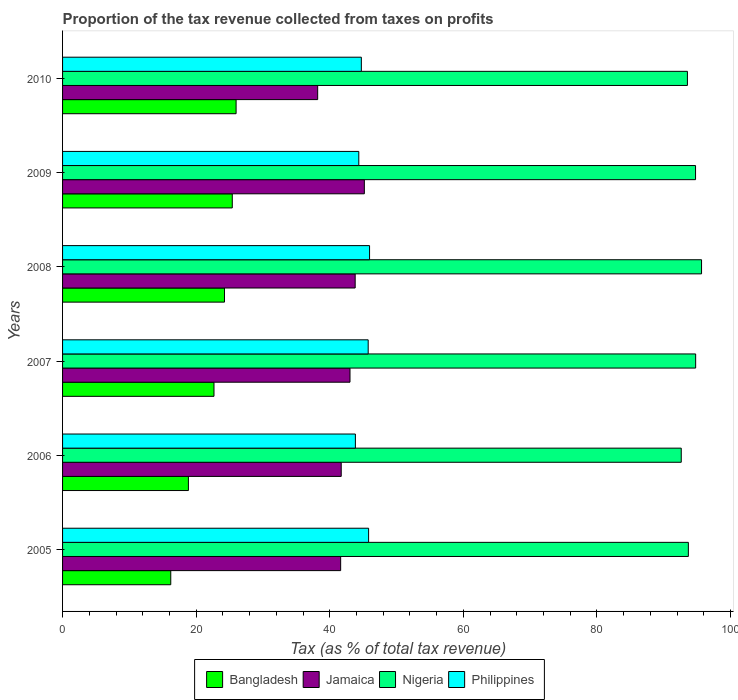How many different coloured bars are there?
Your response must be concise. 4. Are the number of bars per tick equal to the number of legend labels?
Provide a succinct answer. Yes. Are the number of bars on each tick of the Y-axis equal?
Ensure brevity in your answer.  Yes. How many bars are there on the 5th tick from the top?
Provide a short and direct response. 4. What is the proportion of the tax revenue collected in Jamaica in 2006?
Your answer should be compact. 41.72. Across all years, what is the maximum proportion of the tax revenue collected in Jamaica?
Keep it short and to the point. 45.18. Across all years, what is the minimum proportion of the tax revenue collected in Nigeria?
Your response must be concise. 92.63. In which year was the proportion of the tax revenue collected in Jamaica minimum?
Make the answer very short. 2010. What is the total proportion of the tax revenue collected in Nigeria in the graph?
Give a very brief answer. 565.12. What is the difference between the proportion of the tax revenue collected in Nigeria in 2007 and that in 2010?
Provide a succinct answer. 1.23. What is the difference between the proportion of the tax revenue collected in Philippines in 2010 and the proportion of the tax revenue collected in Bangladesh in 2007?
Your answer should be very brief. 22.06. What is the average proportion of the tax revenue collected in Jamaica per year?
Your response must be concise. 42.26. In the year 2008, what is the difference between the proportion of the tax revenue collected in Jamaica and proportion of the tax revenue collected in Nigeria?
Your response must be concise. -51.86. What is the ratio of the proportion of the tax revenue collected in Philippines in 2007 to that in 2009?
Keep it short and to the point. 1.03. Is the difference between the proportion of the tax revenue collected in Jamaica in 2007 and 2010 greater than the difference between the proportion of the tax revenue collected in Nigeria in 2007 and 2010?
Your response must be concise. Yes. What is the difference between the highest and the second highest proportion of the tax revenue collected in Bangladesh?
Give a very brief answer. 0.57. What is the difference between the highest and the lowest proportion of the tax revenue collected in Philippines?
Ensure brevity in your answer.  2.12. What does the 1st bar from the top in 2007 represents?
Your response must be concise. Philippines. What does the 3rd bar from the bottom in 2007 represents?
Offer a terse response. Nigeria. Is it the case that in every year, the sum of the proportion of the tax revenue collected in Nigeria and proportion of the tax revenue collected in Bangladesh is greater than the proportion of the tax revenue collected in Jamaica?
Give a very brief answer. Yes. Are all the bars in the graph horizontal?
Offer a terse response. Yes. How many years are there in the graph?
Provide a short and direct response. 6. Does the graph contain any zero values?
Offer a terse response. No. What is the title of the graph?
Offer a terse response. Proportion of the tax revenue collected from taxes on profits. Does "Vanuatu" appear as one of the legend labels in the graph?
Give a very brief answer. No. What is the label or title of the X-axis?
Ensure brevity in your answer.  Tax (as % of total tax revenue). What is the label or title of the Y-axis?
Keep it short and to the point. Years. What is the Tax (as % of total tax revenue) of Bangladesh in 2005?
Keep it short and to the point. 16.2. What is the Tax (as % of total tax revenue) in Jamaica in 2005?
Keep it short and to the point. 41.64. What is the Tax (as % of total tax revenue) of Nigeria in 2005?
Your response must be concise. 93.7. What is the Tax (as % of total tax revenue) of Philippines in 2005?
Your response must be concise. 45.82. What is the Tax (as % of total tax revenue) of Bangladesh in 2006?
Provide a succinct answer. 18.84. What is the Tax (as % of total tax revenue) in Jamaica in 2006?
Provide a succinct answer. 41.72. What is the Tax (as % of total tax revenue) in Nigeria in 2006?
Ensure brevity in your answer.  92.63. What is the Tax (as % of total tax revenue) of Philippines in 2006?
Ensure brevity in your answer.  43.84. What is the Tax (as % of total tax revenue) in Bangladesh in 2007?
Make the answer very short. 22.67. What is the Tax (as % of total tax revenue) of Jamaica in 2007?
Your answer should be very brief. 43.04. What is the Tax (as % of total tax revenue) in Nigeria in 2007?
Offer a very short reply. 94.79. What is the Tax (as % of total tax revenue) in Philippines in 2007?
Make the answer very short. 45.76. What is the Tax (as % of total tax revenue) in Bangladesh in 2008?
Your response must be concise. 24.24. What is the Tax (as % of total tax revenue) of Jamaica in 2008?
Ensure brevity in your answer.  43.81. What is the Tax (as % of total tax revenue) in Nigeria in 2008?
Make the answer very short. 95.67. What is the Tax (as % of total tax revenue) in Philippines in 2008?
Provide a succinct answer. 45.96. What is the Tax (as % of total tax revenue) of Bangladesh in 2009?
Ensure brevity in your answer.  25.41. What is the Tax (as % of total tax revenue) in Jamaica in 2009?
Your response must be concise. 45.18. What is the Tax (as % of total tax revenue) in Nigeria in 2009?
Provide a short and direct response. 94.77. What is the Tax (as % of total tax revenue) of Philippines in 2009?
Make the answer very short. 44.35. What is the Tax (as % of total tax revenue) of Bangladesh in 2010?
Make the answer very short. 25.98. What is the Tax (as % of total tax revenue) of Jamaica in 2010?
Keep it short and to the point. 38.2. What is the Tax (as % of total tax revenue) in Nigeria in 2010?
Offer a very short reply. 93.55. What is the Tax (as % of total tax revenue) of Philippines in 2010?
Offer a terse response. 44.73. Across all years, what is the maximum Tax (as % of total tax revenue) in Bangladesh?
Offer a terse response. 25.98. Across all years, what is the maximum Tax (as % of total tax revenue) of Jamaica?
Make the answer very short. 45.18. Across all years, what is the maximum Tax (as % of total tax revenue) of Nigeria?
Keep it short and to the point. 95.67. Across all years, what is the maximum Tax (as % of total tax revenue) of Philippines?
Give a very brief answer. 45.96. Across all years, what is the minimum Tax (as % of total tax revenue) in Bangladesh?
Make the answer very short. 16.2. Across all years, what is the minimum Tax (as % of total tax revenue) of Jamaica?
Provide a short and direct response. 38.2. Across all years, what is the minimum Tax (as % of total tax revenue) in Nigeria?
Keep it short and to the point. 92.63. Across all years, what is the minimum Tax (as % of total tax revenue) of Philippines?
Keep it short and to the point. 43.84. What is the total Tax (as % of total tax revenue) of Bangladesh in the graph?
Your response must be concise. 133.34. What is the total Tax (as % of total tax revenue) of Jamaica in the graph?
Offer a terse response. 253.58. What is the total Tax (as % of total tax revenue) of Nigeria in the graph?
Make the answer very short. 565.12. What is the total Tax (as % of total tax revenue) of Philippines in the graph?
Keep it short and to the point. 270.47. What is the difference between the Tax (as % of total tax revenue) in Bangladesh in 2005 and that in 2006?
Keep it short and to the point. -2.64. What is the difference between the Tax (as % of total tax revenue) in Jamaica in 2005 and that in 2006?
Your answer should be compact. -0.08. What is the difference between the Tax (as % of total tax revenue) in Nigeria in 2005 and that in 2006?
Your answer should be very brief. 1.06. What is the difference between the Tax (as % of total tax revenue) of Philippines in 2005 and that in 2006?
Keep it short and to the point. 1.98. What is the difference between the Tax (as % of total tax revenue) in Bangladesh in 2005 and that in 2007?
Your answer should be very brief. -6.47. What is the difference between the Tax (as % of total tax revenue) in Jamaica in 2005 and that in 2007?
Your answer should be very brief. -1.4. What is the difference between the Tax (as % of total tax revenue) in Nigeria in 2005 and that in 2007?
Keep it short and to the point. -1.09. What is the difference between the Tax (as % of total tax revenue) of Philippines in 2005 and that in 2007?
Your answer should be compact. 0.06. What is the difference between the Tax (as % of total tax revenue) in Bangladesh in 2005 and that in 2008?
Give a very brief answer. -8.04. What is the difference between the Tax (as % of total tax revenue) of Jamaica in 2005 and that in 2008?
Provide a succinct answer. -2.17. What is the difference between the Tax (as % of total tax revenue) in Nigeria in 2005 and that in 2008?
Provide a short and direct response. -1.97. What is the difference between the Tax (as % of total tax revenue) of Philippines in 2005 and that in 2008?
Your answer should be compact. -0.14. What is the difference between the Tax (as % of total tax revenue) in Bangladesh in 2005 and that in 2009?
Ensure brevity in your answer.  -9.21. What is the difference between the Tax (as % of total tax revenue) of Jamaica in 2005 and that in 2009?
Offer a very short reply. -3.55. What is the difference between the Tax (as % of total tax revenue) of Nigeria in 2005 and that in 2009?
Ensure brevity in your answer.  -1.08. What is the difference between the Tax (as % of total tax revenue) of Philippines in 2005 and that in 2009?
Offer a terse response. 1.47. What is the difference between the Tax (as % of total tax revenue) in Bangladesh in 2005 and that in 2010?
Ensure brevity in your answer.  -9.78. What is the difference between the Tax (as % of total tax revenue) of Jamaica in 2005 and that in 2010?
Offer a very short reply. 3.44. What is the difference between the Tax (as % of total tax revenue) of Nigeria in 2005 and that in 2010?
Keep it short and to the point. 0.14. What is the difference between the Tax (as % of total tax revenue) of Philippines in 2005 and that in 2010?
Make the answer very short. 1.09. What is the difference between the Tax (as % of total tax revenue) of Bangladesh in 2006 and that in 2007?
Provide a short and direct response. -3.83. What is the difference between the Tax (as % of total tax revenue) in Jamaica in 2006 and that in 2007?
Provide a succinct answer. -1.31. What is the difference between the Tax (as % of total tax revenue) in Nigeria in 2006 and that in 2007?
Offer a terse response. -2.16. What is the difference between the Tax (as % of total tax revenue) of Philippines in 2006 and that in 2007?
Provide a short and direct response. -1.92. What is the difference between the Tax (as % of total tax revenue) in Bangladesh in 2006 and that in 2008?
Your answer should be very brief. -5.4. What is the difference between the Tax (as % of total tax revenue) in Jamaica in 2006 and that in 2008?
Offer a very short reply. -2.09. What is the difference between the Tax (as % of total tax revenue) in Nigeria in 2006 and that in 2008?
Offer a very short reply. -3.04. What is the difference between the Tax (as % of total tax revenue) in Philippines in 2006 and that in 2008?
Your answer should be very brief. -2.12. What is the difference between the Tax (as % of total tax revenue) of Bangladesh in 2006 and that in 2009?
Keep it short and to the point. -6.57. What is the difference between the Tax (as % of total tax revenue) of Jamaica in 2006 and that in 2009?
Your answer should be compact. -3.46. What is the difference between the Tax (as % of total tax revenue) of Nigeria in 2006 and that in 2009?
Offer a very short reply. -2.14. What is the difference between the Tax (as % of total tax revenue) of Philippines in 2006 and that in 2009?
Offer a terse response. -0.51. What is the difference between the Tax (as % of total tax revenue) of Bangladesh in 2006 and that in 2010?
Give a very brief answer. -7.14. What is the difference between the Tax (as % of total tax revenue) of Jamaica in 2006 and that in 2010?
Make the answer very short. 3.53. What is the difference between the Tax (as % of total tax revenue) in Nigeria in 2006 and that in 2010?
Give a very brief answer. -0.92. What is the difference between the Tax (as % of total tax revenue) in Philippines in 2006 and that in 2010?
Make the answer very short. -0.89. What is the difference between the Tax (as % of total tax revenue) of Bangladesh in 2007 and that in 2008?
Ensure brevity in your answer.  -1.57. What is the difference between the Tax (as % of total tax revenue) in Jamaica in 2007 and that in 2008?
Give a very brief answer. -0.77. What is the difference between the Tax (as % of total tax revenue) in Nigeria in 2007 and that in 2008?
Your answer should be very brief. -0.88. What is the difference between the Tax (as % of total tax revenue) of Philippines in 2007 and that in 2008?
Provide a short and direct response. -0.21. What is the difference between the Tax (as % of total tax revenue) of Bangladesh in 2007 and that in 2009?
Give a very brief answer. -2.74. What is the difference between the Tax (as % of total tax revenue) in Jamaica in 2007 and that in 2009?
Make the answer very short. -2.15. What is the difference between the Tax (as % of total tax revenue) of Nigeria in 2007 and that in 2009?
Your answer should be very brief. 0.02. What is the difference between the Tax (as % of total tax revenue) of Philippines in 2007 and that in 2009?
Keep it short and to the point. 1.41. What is the difference between the Tax (as % of total tax revenue) in Bangladesh in 2007 and that in 2010?
Offer a terse response. -3.31. What is the difference between the Tax (as % of total tax revenue) of Jamaica in 2007 and that in 2010?
Your answer should be very brief. 4.84. What is the difference between the Tax (as % of total tax revenue) in Nigeria in 2007 and that in 2010?
Keep it short and to the point. 1.23. What is the difference between the Tax (as % of total tax revenue) of Philippines in 2007 and that in 2010?
Ensure brevity in your answer.  1.03. What is the difference between the Tax (as % of total tax revenue) in Bangladesh in 2008 and that in 2009?
Offer a terse response. -1.17. What is the difference between the Tax (as % of total tax revenue) in Jamaica in 2008 and that in 2009?
Your answer should be very brief. -1.37. What is the difference between the Tax (as % of total tax revenue) in Nigeria in 2008 and that in 2009?
Keep it short and to the point. 0.9. What is the difference between the Tax (as % of total tax revenue) of Philippines in 2008 and that in 2009?
Provide a succinct answer. 1.61. What is the difference between the Tax (as % of total tax revenue) of Bangladesh in 2008 and that in 2010?
Keep it short and to the point. -1.74. What is the difference between the Tax (as % of total tax revenue) of Jamaica in 2008 and that in 2010?
Offer a very short reply. 5.61. What is the difference between the Tax (as % of total tax revenue) of Nigeria in 2008 and that in 2010?
Offer a very short reply. 2.12. What is the difference between the Tax (as % of total tax revenue) of Philippines in 2008 and that in 2010?
Offer a terse response. 1.23. What is the difference between the Tax (as % of total tax revenue) in Bangladesh in 2009 and that in 2010?
Ensure brevity in your answer.  -0.57. What is the difference between the Tax (as % of total tax revenue) of Jamaica in 2009 and that in 2010?
Your answer should be compact. 6.99. What is the difference between the Tax (as % of total tax revenue) of Nigeria in 2009 and that in 2010?
Give a very brief answer. 1.22. What is the difference between the Tax (as % of total tax revenue) in Philippines in 2009 and that in 2010?
Your answer should be very brief. -0.38. What is the difference between the Tax (as % of total tax revenue) of Bangladesh in 2005 and the Tax (as % of total tax revenue) of Jamaica in 2006?
Your answer should be compact. -25.52. What is the difference between the Tax (as % of total tax revenue) in Bangladesh in 2005 and the Tax (as % of total tax revenue) in Nigeria in 2006?
Give a very brief answer. -76.43. What is the difference between the Tax (as % of total tax revenue) in Bangladesh in 2005 and the Tax (as % of total tax revenue) in Philippines in 2006?
Provide a succinct answer. -27.64. What is the difference between the Tax (as % of total tax revenue) of Jamaica in 2005 and the Tax (as % of total tax revenue) of Nigeria in 2006?
Keep it short and to the point. -50.99. What is the difference between the Tax (as % of total tax revenue) in Jamaica in 2005 and the Tax (as % of total tax revenue) in Philippines in 2006?
Provide a short and direct response. -2.21. What is the difference between the Tax (as % of total tax revenue) in Nigeria in 2005 and the Tax (as % of total tax revenue) in Philippines in 2006?
Offer a very short reply. 49.85. What is the difference between the Tax (as % of total tax revenue) in Bangladesh in 2005 and the Tax (as % of total tax revenue) in Jamaica in 2007?
Your response must be concise. -26.84. What is the difference between the Tax (as % of total tax revenue) of Bangladesh in 2005 and the Tax (as % of total tax revenue) of Nigeria in 2007?
Make the answer very short. -78.59. What is the difference between the Tax (as % of total tax revenue) in Bangladesh in 2005 and the Tax (as % of total tax revenue) in Philippines in 2007?
Provide a short and direct response. -29.56. What is the difference between the Tax (as % of total tax revenue) in Jamaica in 2005 and the Tax (as % of total tax revenue) in Nigeria in 2007?
Give a very brief answer. -53.15. What is the difference between the Tax (as % of total tax revenue) of Jamaica in 2005 and the Tax (as % of total tax revenue) of Philippines in 2007?
Provide a succinct answer. -4.12. What is the difference between the Tax (as % of total tax revenue) of Nigeria in 2005 and the Tax (as % of total tax revenue) of Philippines in 2007?
Offer a very short reply. 47.94. What is the difference between the Tax (as % of total tax revenue) in Bangladesh in 2005 and the Tax (as % of total tax revenue) in Jamaica in 2008?
Offer a terse response. -27.61. What is the difference between the Tax (as % of total tax revenue) of Bangladesh in 2005 and the Tax (as % of total tax revenue) of Nigeria in 2008?
Keep it short and to the point. -79.47. What is the difference between the Tax (as % of total tax revenue) of Bangladesh in 2005 and the Tax (as % of total tax revenue) of Philippines in 2008?
Your answer should be compact. -29.77. What is the difference between the Tax (as % of total tax revenue) in Jamaica in 2005 and the Tax (as % of total tax revenue) in Nigeria in 2008?
Your answer should be very brief. -54.03. What is the difference between the Tax (as % of total tax revenue) in Jamaica in 2005 and the Tax (as % of total tax revenue) in Philippines in 2008?
Offer a terse response. -4.33. What is the difference between the Tax (as % of total tax revenue) of Nigeria in 2005 and the Tax (as % of total tax revenue) of Philippines in 2008?
Provide a short and direct response. 47.73. What is the difference between the Tax (as % of total tax revenue) of Bangladesh in 2005 and the Tax (as % of total tax revenue) of Jamaica in 2009?
Your response must be concise. -28.98. What is the difference between the Tax (as % of total tax revenue) in Bangladesh in 2005 and the Tax (as % of total tax revenue) in Nigeria in 2009?
Make the answer very short. -78.57. What is the difference between the Tax (as % of total tax revenue) in Bangladesh in 2005 and the Tax (as % of total tax revenue) in Philippines in 2009?
Your response must be concise. -28.15. What is the difference between the Tax (as % of total tax revenue) in Jamaica in 2005 and the Tax (as % of total tax revenue) in Nigeria in 2009?
Provide a succinct answer. -53.14. What is the difference between the Tax (as % of total tax revenue) in Jamaica in 2005 and the Tax (as % of total tax revenue) in Philippines in 2009?
Your answer should be compact. -2.71. What is the difference between the Tax (as % of total tax revenue) in Nigeria in 2005 and the Tax (as % of total tax revenue) in Philippines in 2009?
Offer a terse response. 49.34. What is the difference between the Tax (as % of total tax revenue) of Bangladesh in 2005 and the Tax (as % of total tax revenue) of Jamaica in 2010?
Ensure brevity in your answer.  -22. What is the difference between the Tax (as % of total tax revenue) in Bangladesh in 2005 and the Tax (as % of total tax revenue) in Nigeria in 2010?
Make the answer very short. -77.36. What is the difference between the Tax (as % of total tax revenue) in Bangladesh in 2005 and the Tax (as % of total tax revenue) in Philippines in 2010?
Provide a short and direct response. -28.53. What is the difference between the Tax (as % of total tax revenue) in Jamaica in 2005 and the Tax (as % of total tax revenue) in Nigeria in 2010?
Provide a succinct answer. -51.92. What is the difference between the Tax (as % of total tax revenue) of Jamaica in 2005 and the Tax (as % of total tax revenue) of Philippines in 2010?
Keep it short and to the point. -3.1. What is the difference between the Tax (as % of total tax revenue) of Nigeria in 2005 and the Tax (as % of total tax revenue) of Philippines in 2010?
Give a very brief answer. 48.96. What is the difference between the Tax (as % of total tax revenue) of Bangladesh in 2006 and the Tax (as % of total tax revenue) of Jamaica in 2007?
Offer a very short reply. -24.2. What is the difference between the Tax (as % of total tax revenue) of Bangladesh in 2006 and the Tax (as % of total tax revenue) of Nigeria in 2007?
Offer a very short reply. -75.95. What is the difference between the Tax (as % of total tax revenue) in Bangladesh in 2006 and the Tax (as % of total tax revenue) in Philippines in 2007?
Keep it short and to the point. -26.92. What is the difference between the Tax (as % of total tax revenue) of Jamaica in 2006 and the Tax (as % of total tax revenue) of Nigeria in 2007?
Your answer should be compact. -53.07. What is the difference between the Tax (as % of total tax revenue) in Jamaica in 2006 and the Tax (as % of total tax revenue) in Philippines in 2007?
Your answer should be very brief. -4.04. What is the difference between the Tax (as % of total tax revenue) of Nigeria in 2006 and the Tax (as % of total tax revenue) of Philippines in 2007?
Provide a short and direct response. 46.87. What is the difference between the Tax (as % of total tax revenue) in Bangladesh in 2006 and the Tax (as % of total tax revenue) in Jamaica in 2008?
Make the answer very short. -24.97. What is the difference between the Tax (as % of total tax revenue) in Bangladesh in 2006 and the Tax (as % of total tax revenue) in Nigeria in 2008?
Give a very brief answer. -76.83. What is the difference between the Tax (as % of total tax revenue) of Bangladesh in 2006 and the Tax (as % of total tax revenue) of Philippines in 2008?
Provide a succinct answer. -27.12. What is the difference between the Tax (as % of total tax revenue) in Jamaica in 2006 and the Tax (as % of total tax revenue) in Nigeria in 2008?
Your answer should be very brief. -53.95. What is the difference between the Tax (as % of total tax revenue) in Jamaica in 2006 and the Tax (as % of total tax revenue) in Philippines in 2008?
Your answer should be compact. -4.24. What is the difference between the Tax (as % of total tax revenue) of Nigeria in 2006 and the Tax (as % of total tax revenue) of Philippines in 2008?
Give a very brief answer. 46.67. What is the difference between the Tax (as % of total tax revenue) in Bangladesh in 2006 and the Tax (as % of total tax revenue) in Jamaica in 2009?
Offer a very short reply. -26.34. What is the difference between the Tax (as % of total tax revenue) in Bangladesh in 2006 and the Tax (as % of total tax revenue) in Nigeria in 2009?
Make the answer very short. -75.93. What is the difference between the Tax (as % of total tax revenue) in Bangladesh in 2006 and the Tax (as % of total tax revenue) in Philippines in 2009?
Give a very brief answer. -25.51. What is the difference between the Tax (as % of total tax revenue) of Jamaica in 2006 and the Tax (as % of total tax revenue) of Nigeria in 2009?
Your response must be concise. -53.05. What is the difference between the Tax (as % of total tax revenue) in Jamaica in 2006 and the Tax (as % of total tax revenue) in Philippines in 2009?
Provide a short and direct response. -2.63. What is the difference between the Tax (as % of total tax revenue) in Nigeria in 2006 and the Tax (as % of total tax revenue) in Philippines in 2009?
Provide a short and direct response. 48.28. What is the difference between the Tax (as % of total tax revenue) of Bangladesh in 2006 and the Tax (as % of total tax revenue) of Jamaica in 2010?
Offer a very short reply. -19.35. What is the difference between the Tax (as % of total tax revenue) in Bangladesh in 2006 and the Tax (as % of total tax revenue) in Nigeria in 2010?
Your answer should be compact. -74.71. What is the difference between the Tax (as % of total tax revenue) in Bangladesh in 2006 and the Tax (as % of total tax revenue) in Philippines in 2010?
Your response must be concise. -25.89. What is the difference between the Tax (as % of total tax revenue) in Jamaica in 2006 and the Tax (as % of total tax revenue) in Nigeria in 2010?
Provide a succinct answer. -51.83. What is the difference between the Tax (as % of total tax revenue) in Jamaica in 2006 and the Tax (as % of total tax revenue) in Philippines in 2010?
Give a very brief answer. -3.01. What is the difference between the Tax (as % of total tax revenue) in Nigeria in 2006 and the Tax (as % of total tax revenue) in Philippines in 2010?
Your answer should be very brief. 47.9. What is the difference between the Tax (as % of total tax revenue) of Bangladesh in 2007 and the Tax (as % of total tax revenue) of Jamaica in 2008?
Your answer should be very brief. -21.14. What is the difference between the Tax (as % of total tax revenue) of Bangladesh in 2007 and the Tax (as % of total tax revenue) of Nigeria in 2008?
Keep it short and to the point. -73. What is the difference between the Tax (as % of total tax revenue) of Bangladesh in 2007 and the Tax (as % of total tax revenue) of Philippines in 2008?
Your response must be concise. -23.29. What is the difference between the Tax (as % of total tax revenue) in Jamaica in 2007 and the Tax (as % of total tax revenue) in Nigeria in 2008?
Provide a short and direct response. -52.63. What is the difference between the Tax (as % of total tax revenue) of Jamaica in 2007 and the Tax (as % of total tax revenue) of Philippines in 2008?
Your response must be concise. -2.93. What is the difference between the Tax (as % of total tax revenue) of Nigeria in 2007 and the Tax (as % of total tax revenue) of Philippines in 2008?
Provide a short and direct response. 48.82. What is the difference between the Tax (as % of total tax revenue) of Bangladesh in 2007 and the Tax (as % of total tax revenue) of Jamaica in 2009?
Your answer should be compact. -22.51. What is the difference between the Tax (as % of total tax revenue) of Bangladesh in 2007 and the Tax (as % of total tax revenue) of Nigeria in 2009?
Your answer should be compact. -72.1. What is the difference between the Tax (as % of total tax revenue) in Bangladesh in 2007 and the Tax (as % of total tax revenue) in Philippines in 2009?
Your response must be concise. -21.68. What is the difference between the Tax (as % of total tax revenue) in Jamaica in 2007 and the Tax (as % of total tax revenue) in Nigeria in 2009?
Your response must be concise. -51.74. What is the difference between the Tax (as % of total tax revenue) of Jamaica in 2007 and the Tax (as % of total tax revenue) of Philippines in 2009?
Offer a terse response. -1.32. What is the difference between the Tax (as % of total tax revenue) of Nigeria in 2007 and the Tax (as % of total tax revenue) of Philippines in 2009?
Make the answer very short. 50.44. What is the difference between the Tax (as % of total tax revenue) of Bangladesh in 2007 and the Tax (as % of total tax revenue) of Jamaica in 2010?
Keep it short and to the point. -15.52. What is the difference between the Tax (as % of total tax revenue) of Bangladesh in 2007 and the Tax (as % of total tax revenue) of Nigeria in 2010?
Provide a short and direct response. -70.88. What is the difference between the Tax (as % of total tax revenue) in Bangladesh in 2007 and the Tax (as % of total tax revenue) in Philippines in 2010?
Offer a terse response. -22.06. What is the difference between the Tax (as % of total tax revenue) of Jamaica in 2007 and the Tax (as % of total tax revenue) of Nigeria in 2010?
Your response must be concise. -50.52. What is the difference between the Tax (as % of total tax revenue) of Jamaica in 2007 and the Tax (as % of total tax revenue) of Philippines in 2010?
Make the answer very short. -1.7. What is the difference between the Tax (as % of total tax revenue) in Nigeria in 2007 and the Tax (as % of total tax revenue) in Philippines in 2010?
Offer a very short reply. 50.06. What is the difference between the Tax (as % of total tax revenue) in Bangladesh in 2008 and the Tax (as % of total tax revenue) in Jamaica in 2009?
Your response must be concise. -20.94. What is the difference between the Tax (as % of total tax revenue) in Bangladesh in 2008 and the Tax (as % of total tax revenue) in Nigeria in 2009?
Offer a very short reply. -70.53. What is the difference between the Tax (as % of total tax revenue) of Bangladesh in 2008 and the Tax (as % of total tax revenue) of Philippines in 2009?
Your answer should be compact. -20.11. What is the difference between the Tax (as % of total tax revenue) of Jamaica in 2008 and the Tax (as % of total tax revenue) of Nigeria in 2009?
Make the answer very short. -50.96. What is the difference between the Tax (as % of total tax revenue) of Jamaica in 2008 and the Tax (as % of total tax revenue) of Philippines in 2009?
Provide a succinct answer. -0.54. What is the difference between the Tax (as % of total tax revenue) of Nigeria in 2008 and the Tax (as % of total tax revenue) of Philippines in 2009?
Make the answer very short. 51.32. What is the difference between the Tax (as % of total tax revenue) in Bangladesh in 2008 and the Tax (as % of total tax revenue) in Jamaica in 2010?
Your answer should be very brief. -13.95. What is the difference between the Tax (as % of total tax revenue) of Bangladesh in 2008 and the Tax (as % of total tax revenue) of Nigeria in 2010?
Offer a very short reply. -69.31. What is the difference between the Tax (as % of total tax revenue) in Bangladesh in 2008 and the Tax (as % of total tax revenue) in Philippines in 2010?
Offer a terse response. -20.49. What is the difference between the Tax (as % of total tax revenue) in Jamaica in 2008 and the Tax (as % of total tax revenue) in Nigeria in 2010?
Make the answer very short. -49.74. What is the difference between the Tax (as % of total tax revenue) in Jamaica in 2008 and the Tax (as % of total tax revenue) in Philippines in 2010?
Provide a short and direct response. -0.92. What is the difference between the Tax (as % of total tax revenue) in Nigeria in 2008 and the Tax (as % of total tax revenue) in Philippines in 2010?
Provide a succinct answer. 50.94. What is the difference between the Tax (as % of total tax revenue) of Bangladesh in 2009 and the Tax (as % of total tax revenue) of Jamaica in 2010?
Make the answer very short. -12.79. What is the difference between the Tax (as % of total tax revenue) in Bangladesh in 2009 and the Tax (as % of total tax revenue) in Nigeria in 2010?
Ensure brevity in your answer.  -68.15. What is the difference between the Tax (as % of total tax revenue) in Bangladesh in 2009 and the Tax (as % of total tax revenue) in Philippines in 2010?
Provide a short and direct response. -19.32. What is the difference between the Tax (as % of total tax revenue) of Jamaica in 2009 and the Tax (as % of total tax revenue) of Nigeria in 2010?
Keep it short and to the point. -48.37. What is the difference between the Tax (as % of total tax revenue) of Jamaica in 2009 and the Tax (as % of total tax revenue) of Philippines in 2010?
Offer a very short reply. 0.45. What is the difference between the Tax (as % of total tax revenue) of Nigeria in 2009 and the Tax (as % of total tax revenue) of Philippines in 2010?
Your answer should be compact. 50.04. What is the average Tax (as % of total tax revenue) of Bangladesh per year?
Offer a terse response. 22.22. What is the average Tax (as % of total tax revenue) in Jamaica per year?
Your response must be concise. 42.26. What is the average Tax (as % of total tax revenue) in Nigeria per year?
Your answer should be very brief. 94.19. What is the average Tax (as % of total tax revenue) of Philippines per year?
Keep it short and to the point. 45.08. In the year 2005, what is the difference between the Tax (as % of total tax revenue) of Bangladesh and Tax (as % of total tax revenue) of Jamaica?
Your answer should be very brief. -25.44. In the year 2005, what is the difference between the Tax (as % of total tax revenue) of Bangladesh and Tax (as % of total tax revenue) of Nigeria?
Offer a terse response. -77.5. In the year 2005, what is the difference between the Tax (as % of total tax revenue) of Bangladesh and Tax (as % of total tax revenue) of Philippines?
Offer a very short reply. -29.62. In the year 2005, what is the difference between the Tax (as % of total tax revenue) of Jamaica and Tax (as % of total tax revenue) of Nigeria?
Ensure brevity in your answer.  -52.06. In the year 2005, what is the difference between the Tax (as % of total tax revenue) in Jamaica and Tax (as % of total tax revenue) in Philippines?
Keep it short and to the point. -4.18. In the year 2005, what is the difference between the Tax (as % of total tax revenue) in Nigeria and Tax (as % of total tax revenue) in Philippines?
Your answer should be compact. 47.87. In the year 2006, what is the difference between the Tax (as % of total tax revenue) in Bangladesh and Tax (as % of total tax revenue) in Jamaica?
Make the answer very short. -22.88. In the year 2006, what is the difference between the Tax (as % of total tax revenue) in Bangladesh and Tax (as % of total tax revenue) in Nigeria?
Offer a terse response. -73.79. In the year 2006, what is the difference between the Tax (as % of total tax revenue) in Bangladesh and Tax (as % of total tax revenue) in Philippines?
Your answer should be very brief. -25. In the year 2006, what is the difference between the Tax (as % of total tax revenue) of Jamaica and Tax (as % of total tax revenue) of Nigeria?
Your answer should be compact. -50.91. In the year 2006, what is the difference between the Tax (as % of total tax revenue) in Jamaica and Tax (as % of total tax revenue) in Philippines?
Your response must be concise. -2.12. In the year 2006, what is the difference between the Tax (as % of total tax revenue) of Nigeria and Tax (as % of total tax revenue) of Philippines?
Give a very brief answer. 48.79. In the year 2007, what is the difference between the Tax (as % of total tax revenue) in Bangladesh and Tax (as % of total tax revenue) in Jamaica?
Your answer should be very brief. -20.37. In the year 2007, what is the difference between the Tax (as % of total tax revenue) of Bangladesh and Tax (as % of total tax revenue) of Nigeria?
Ensure brevity in your answer.  -72.12. In the year 2007, what is the difference between the Tax (as % of total tax revenue) in Bangladesh and Tax (as % of total tax revenue) in Philippines?
Make the answer very short. -23.09. In the year 2007, what is the difference between the Tax (as % of total tax revenue) of Jamaica and Tax (as % of total tax revenue) of Nigeria?
Ensure brevity in your answer.  -51.75. In the year 2007, what is the difference between the Tax (as % of total tax revenue) in Jamaica and Tax (as % of total tax revenue) in Philippines?
Provide a short and direct response. -2.72. In the year 2007, what is the difference between the Tax (as % of total tax revenue) in Nigeria and Tax (as % of total tax revenue) in Philippines?
Your answer should be compact. 49.03. In the year 2008, what is the difference between the Tax (as % of total tax revenue) in Bangladesh and Tax (as % of total tax revenue) in Jamaica?
Keep it short and to the point. -19.57. In the year 2008, what is the difference between the Tax (as % of total tax revenue) of Bangladesh and Tax (as % of total tax revenue) of Nigeria?
Offer a very short reply. -71.43. In the year 2008, what is the difference between the Tax (as % of total tax revenue) in Bangladesh and Tax (as % of total tax revenue) in Philippines?
Offer a very short reply. -21.72. In the year 2008, what is the difference between the Tax (as % of total tax revenue) of Jamaica and Tax (as % of total tax revenue) of Nigeria?
Keep it short and to the point. -51.86. In the year 2008, what is the difference between the Tax (as % of total tax revenue) of Jamaica and Tax (as % of total tax revenue) of Philippines?
Your answer should be very brief. -2.15. In the year 2008, what is the difference between the Tax (as % of total tax revenue) of Nigeria and Tax (as % of total tax revenue) of Philippines?
Provide a succinct answer. 49.71. In the year 2009, what is the difference between the Tax (as % of total tax revenue) in Bangladesh and Tax (as % of total tax revenue) in Jamaica?
Provide a short and direct response. -19.77. In the year 2009, what is the difference between the Tax (as % of total tax revenue) of Bangladesh and Tax (as % of total tax revenue) of Nigeria?
Provide a succinct answer. -69.36. In the year 2009, what is the difference between the Tax (as % of total tax revenue) of Bangladesh and Tax (as % of total tax revenue) of Philippines?
Ensure brevity in your answer.  -18.94. In the year 2009, what is the difference between the Tax (as % of total tax revenue) of Jamaica and Tax (as % of total tax revenue) of Nigeria?
Make the answer very short. -49.59. In the year 2009, what is the difference between the Tax (as % of total tax revenue) in Jamaica and Tax (as % of total tax revenue) in Philippines?
Your response must be concise. 0.83. In the year 2009, what is the difference between the Tax (as % of total tax revenue) of Nigeria and Tax (as % of total tax revenue) of Philippines?
Give a very brief answer. 50.42. In the year 2010, what is the difference between the Tax (as % of total tax revenue) in Bangladesh and Tax (as % of total tax revenue) in Jamaica?
Your response must be concise. -12.21. In the year 2010, what is the difference between the Tax (as % of total tax revenue) of Bangladesh and Tax (as % of total tax revenue) of Nigeria?
Provide a short and direct response. -67.57. In the year 2010, what is the difference between the Tax (as % of total tax revenue) of Bangladesh and Tax (as % of total tax revenue) of Philippines?
Provide a short and direct response. -18.75. In the year 2010, what is the difference between the Tax (as % of total tax revenue) in Jamaica and Tax (as % of total tax revenue) in Nigeria?
Your answer should be very brief. -55.36. In the year 2010, what is the difference between the Tax (as % of total tax revenue) of Jamaica and Tax (as % of total tax revenue) of Philippines?
Your answer should be compact. -6.54. In the year 2010, what is the difference between the Tax (as % of total tax revenue) in Nigeria and Tax (as % of total tax revenue) in Philippines?
Your answer should be compact. 48.82. What is the ratio of the Tax (as % of total tax revenue) in Bangladesh in 2005 to that in 2006?
Ensure brevity in your answer.  0.86. What is the ratio of the Tax (as % of total tax revenue) of Nigeria in 2005 to that in 2006?
Give a very brief answer. 1.01. What is the ratio of the Tax (as % of total tax revenue) in Philippines in 2005 to that in 2006?
Your answer should be very brief. 1.05. What is the ratio of the Tax (as % of total tax revenue) in Bangladesh in 2005 to that in 2007?
Offer a very short reply. 0.71. What is the ratio of the Tax (as % of total tax revenue) of Jamaica in 2005 to that in 2007?
Provide a succinct answer. 0.97. What is the ratio of the Tax (as % of total tax revenue) of Bangladesh in 2005 to that in 2008?
Your response must be concise. 0.67. What is the ratio of the Tax (as % of total tax revenue) of Jamaica in 2005 to that in 2008?
Keep it short and to the point. 0.95. What is the ratio of the Tax (as % of total tax revenue) in Nigeria in 2005 to that in 2008?
Your answer should be compact. 0.98. What is the ratio of the Tax (as % of total tax revenue) of Philippines in 2005 to that in 2008?
Your response must be concise. 1. What is the ratio of the Tax (as % of total tax revenue) in Bangladesh in 2005 to that in 2009?
Your response must be concise. 0.64. What is the ratio of the Tax (as % of total tax revenue) in Jamaica in 2005 to that in 2009?
Make the answer very short. 0.92. What is the ratio of the Tax (as % of total tax revenue) in Nigeria in 2005 to that in 2009?
Give a very brief answer. 0.99. What is the ratio of the Tax (as % of total tax revenue) of Philippines in 2005 to that in 2009?
Your response must be concise. 1.03. What is the ratio of the Tax (as % of total tax revenue) in Bangladesh in 2005 to that in 2010?
Keep it short and to the point. 0.62. What is the ratio of the Tax (as % of total tax revenue) in Jamaica in 2005 to that in 2010?
Provide a succinct answer. 1.09. What is the ratio of the Tax (as % of total tax revenue) of Philippines in 2005 to that in 2010?
Keep it short and to the point. 1.02. What is the ratio of the Tax (as % of total tax revenue) of Bangladesh in 2006 to that in 2007?
Offer a very short reply. 0.83. What is the ratio of the Tax (as % of total tax revenue) of Jamaica in 2006 to that in 2007?
Offer a very short reply. 0.97. What is the ratio of the Tax (as % of total tax revenue) in Nigeria in 2006 to that in 2007?
Offer a very short reply. 0.98. What is the ratio of the Tax (as % of total tax revenue) of Philippines in 2006 to that in 2007?
Give a very brief answer. 0.96. What is the ratio of the Tax (as % of total tax revenue) in Bangladesh in 2006 to that in 2008?
Provide a short and direct response. 0.78. What is the ratio of the Tax (as % of total tax revenue) in Jamaica in 2006 to that in 2008?
Ensure brevity in your answer.  0.95. What is the ratio of the Tax (as % of total tax revenue) of Nigeria in 2006 to that in 2008?
Provide a short and direct response. 0.97. What is the ratio of the Tax (as % of total tax revenue) of Philippines in 2006 to that in 2008?
Your answer should be compact. 0.95. What is the ratio of the Tax (as % of total tax revenue) in Bangladesh in 2006 to that in 2009?
Make the answer very short. 0.74. What is the ratio of the Tax (as % of total tax revenue) of Jamaica in 2006 to that in 2009?
Ensure brevity in your answer.  0.92. What is the ratio of the Tax (as % of total tax revenue) in Nigeria in 2006 to that in 2009?
Keep it short and to the point. 0.98. What is the ratio of the Tax (as % of total tax revenue) in Bangladesh in 2006 to that in 2010?
Provide a succinct answer. 0.73. What is the ratio of the Tax (as % of total tax revenue) of Jamaica in 2006 to that in 2010?
Keep it short and to the point. 1.09. What is the ratio of the Tax (as % of total tax revenue) of Nigeria in 2006 to that in 2010?
Provide a succinct answer. 0.99. What is the ratio of the Tax (as % of total tax revenue) of Philippines in 2006 to that in 2010?
Make the answer very short. 0.98. What is the ratio of the Tax (as % of total tax revenue) of Bangladesh in 2007 to that in 2008?
Ensure brevity in your answer.  0.94. What is the ratio of the Tax (as % of total tax revenue) of Jamaica in 2007 to that in 2008?
Make the answer very short. 0.98. What is the ratio of the Tax (as % of total tax revenue) of Nigeria in 2007 to that in 2008?
Your answer should be compact. 0.99. What is the ratio of the Tax (as % of total tax revenue) of Bangladesh in 2007 to that in 2009?
Offer a terse response. 0.89. What is the ratio of the Tax (as % of total tax revenue) in Jamaica in 2007 to that in 2009?
Give a very brief answer. 0.95. What is the ratio of the Tax (as % of total tax revenue) in Nigeria in 2007 to that in 2009?
Keep it short and to the point. 1. What is the ratio of the Tax (as % of total tax revenue) in Philippines in 2007 to that in 2009?
Your answer should be very brief. 1.03. What is the ratio of the Tax (as % of total tax revenue) in Bangladesh in 2007 to that in 2010?
Your answer should be compact. 0.87. What is the ratio of the Tax (as % of total tax revenue) in Jamaica in 2007 to that in 2010?
Provide a short and direct response. 1.13. What is the ratio of the Tax (as % of total tax revenue) of Nigeria in 2007 to that in 2010?
Keep it short and to the point. 1.01. What is the ratio of the Tax (as % of total tax revenue) of Philippines in 2007 to that in 2010?
Provide a short and direct response. 1.02. What is the ratio of the Tax (as % of total tax revenue) of Bangladesh in 2008 to that in 2009?
Give a very brief answer. 0.95. What is the ratio of the Tax (as % of total tax revenue) of Jamaica in 2008 to that in 2009?
Your answer should be very brief. 0.97. What is the ratio of the Tax (as % of total tax revenue) of Nigeria in 2008 to that in 2009?
Provide a short and direct response. 1.01. What is the ratio of the Tax (as % of total tax revenue) in Philippines in 2008 to that in 2009?
Your response must be concise. 1.04. What is the ratio of the Tax (as % of total tax revenue) of Bangladesh in 2008 to that in 2010?
Ensure brevity in your answer.  0.93. What is the ratio of the Tax (as % of total tax revenue) in Jamaica in 2008 to that in 2010?
Your answer should be compact. 1.15. What is the ratio of the Tax (as % of total tax revenue) of Nigeria in 2008 to that in 2010?
Your response must be concise. 1.02. What is the ratio of the Tax (as % of total tax revenue) of Philippines in 2008 to that in 2010?
Ensure brevity in your answer.  1.03. What is the ratio of the Tax (as % of total tax revenue) of Jamaica in 2009 to that in 2010?
Offer a terse response. 1.18. What is the ratio of the Tax (as % of total tax revenue) of Nigeria in 2009 to that in 2010?
Offer a terse response. 1.01. What is the difference between the highest and the second highest Tax (as % of total tax revenue) of Bangladesh?
Ensure brevity in your answer.  0.57. What is the difference between the highest and the second highest Tax (as % of total tax revenue) of Jamaica?
Provide a short and direct response. 1.37. What is the difference between the highest and the second highest Tax (as % of total tax revenue) in Nigeria?
Keep it short and to the point. 0.88. What is the difference between the highest and the second highest Tax (as % of total tax revenue) in Philippines?
Your answer should be very brief. 0.14. What is the difference between the highest and the lowest Tax (as % of total tax revenue) in Bangladesh?
Give a very brief answer. 9.78. What is the difference between the highest and the lowest Tax (as % of total tax revenue) of Jamaica?
Provide a short and direct response. 6.99. What is the difference between the highest and the lowest Tax (as % of total tax revenue) of Nigeria?
Ensure brevity in your answer.  3.04. What is the difference between the highest and the lowest Tax (as % of total tax revenue) in Philippines?
Keep it short and to the point. 2.12. 